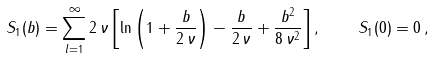<formula> <loc_0><loc_0><loc_500><loc_500>S _ { 1 } ( b ) = \sum _ { l = 1 } ^ { \infty } 2 \, \nu \left [ \ln \left ( 1 + \frac { b } { 2 \, \nu } \right ) - \frac { b } { 2 \, \nu } + \frac { b ^ { 2 } } { 8 \, \nu ^ { 2 } } \right ] , \quad S _ { 1 } ( 0 ) = 0 \, { , }</formula> 